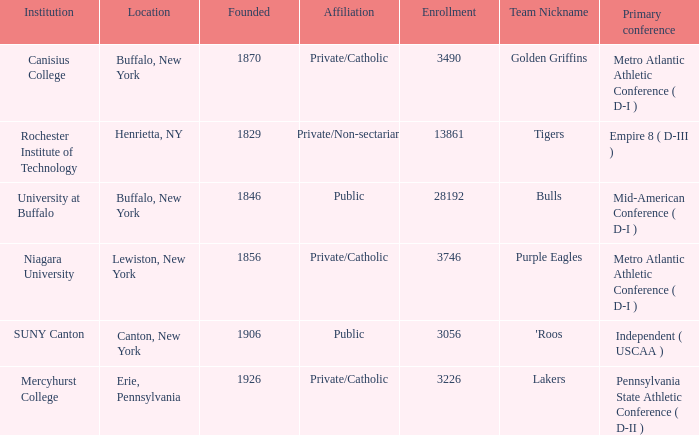What was the enrollment of the school founded in 1846? 28192.0. 